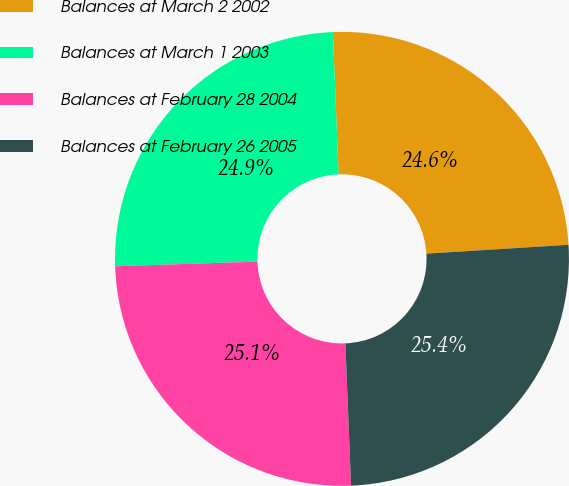Convert chart to OTSL. <chart><loc_0><loc_0><loc_500><loc_500><pie_chart><fcel>Balances at March 2 2002<fcel>Balances at March 1 2003<fcel>Balances at February 28 2004<fcel>Balances at February 26 2005<nl><fcel>24.65%<fcel>24.88%<fcel>25.12%<fcel>25.35%<nl></chart> 